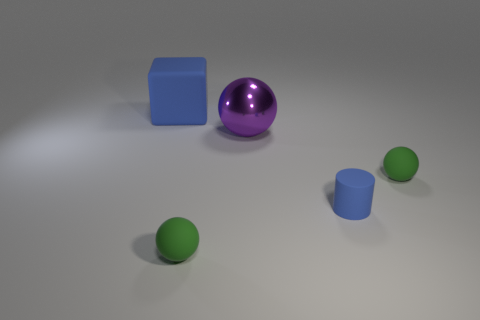Add 1 matte cylinders. How many objects exist? 6 Subtract all spheres. How many objects are left? 2 Subtract 0 blue spheres. How many objects are left? 5 Subtract all big gray matte cylinders. Subtract all big balls. How many objects are left? 4 Add 5 spheres. How many spheres are left? 8 Add 5 small cyan cylinders. How many small cyan cylinders exist? 5 